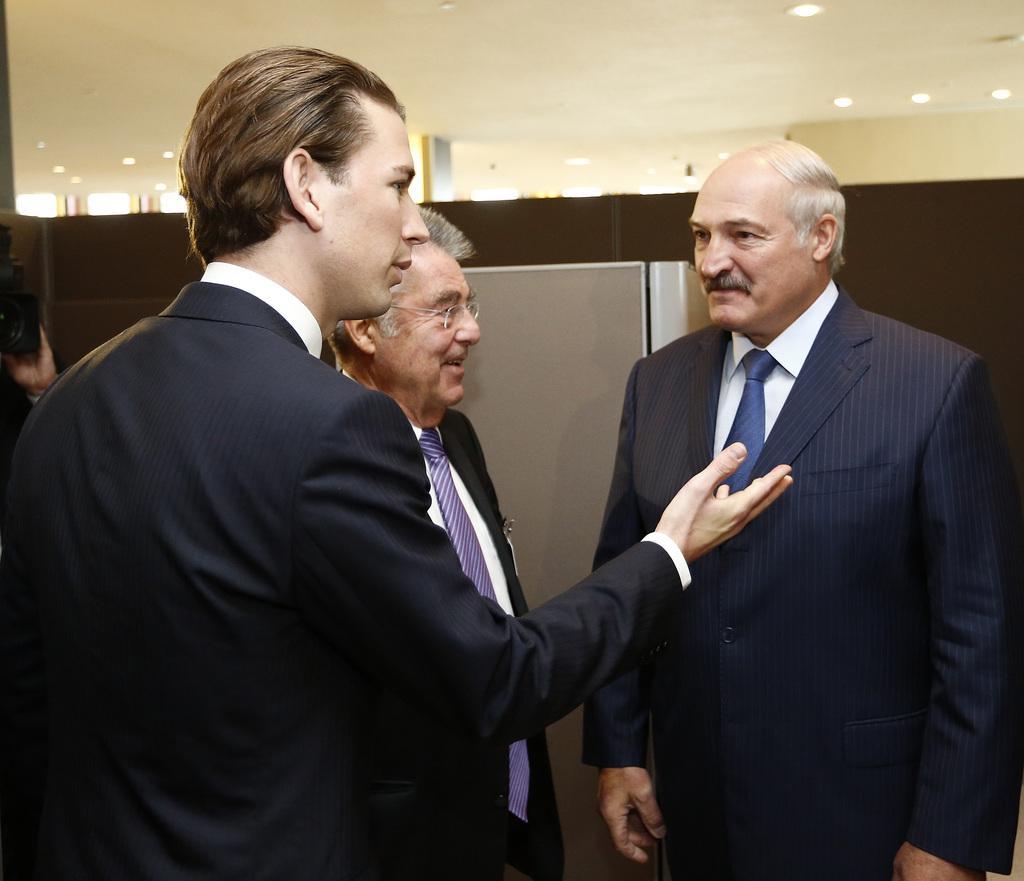How would you summarize this image in a sentence or two? In the foreground of this image, there are three men wearing suits are standing. On the left, there is a camera and a hand of a person. Behind them, there is an object and at the top, there are lights to the ceiling. 